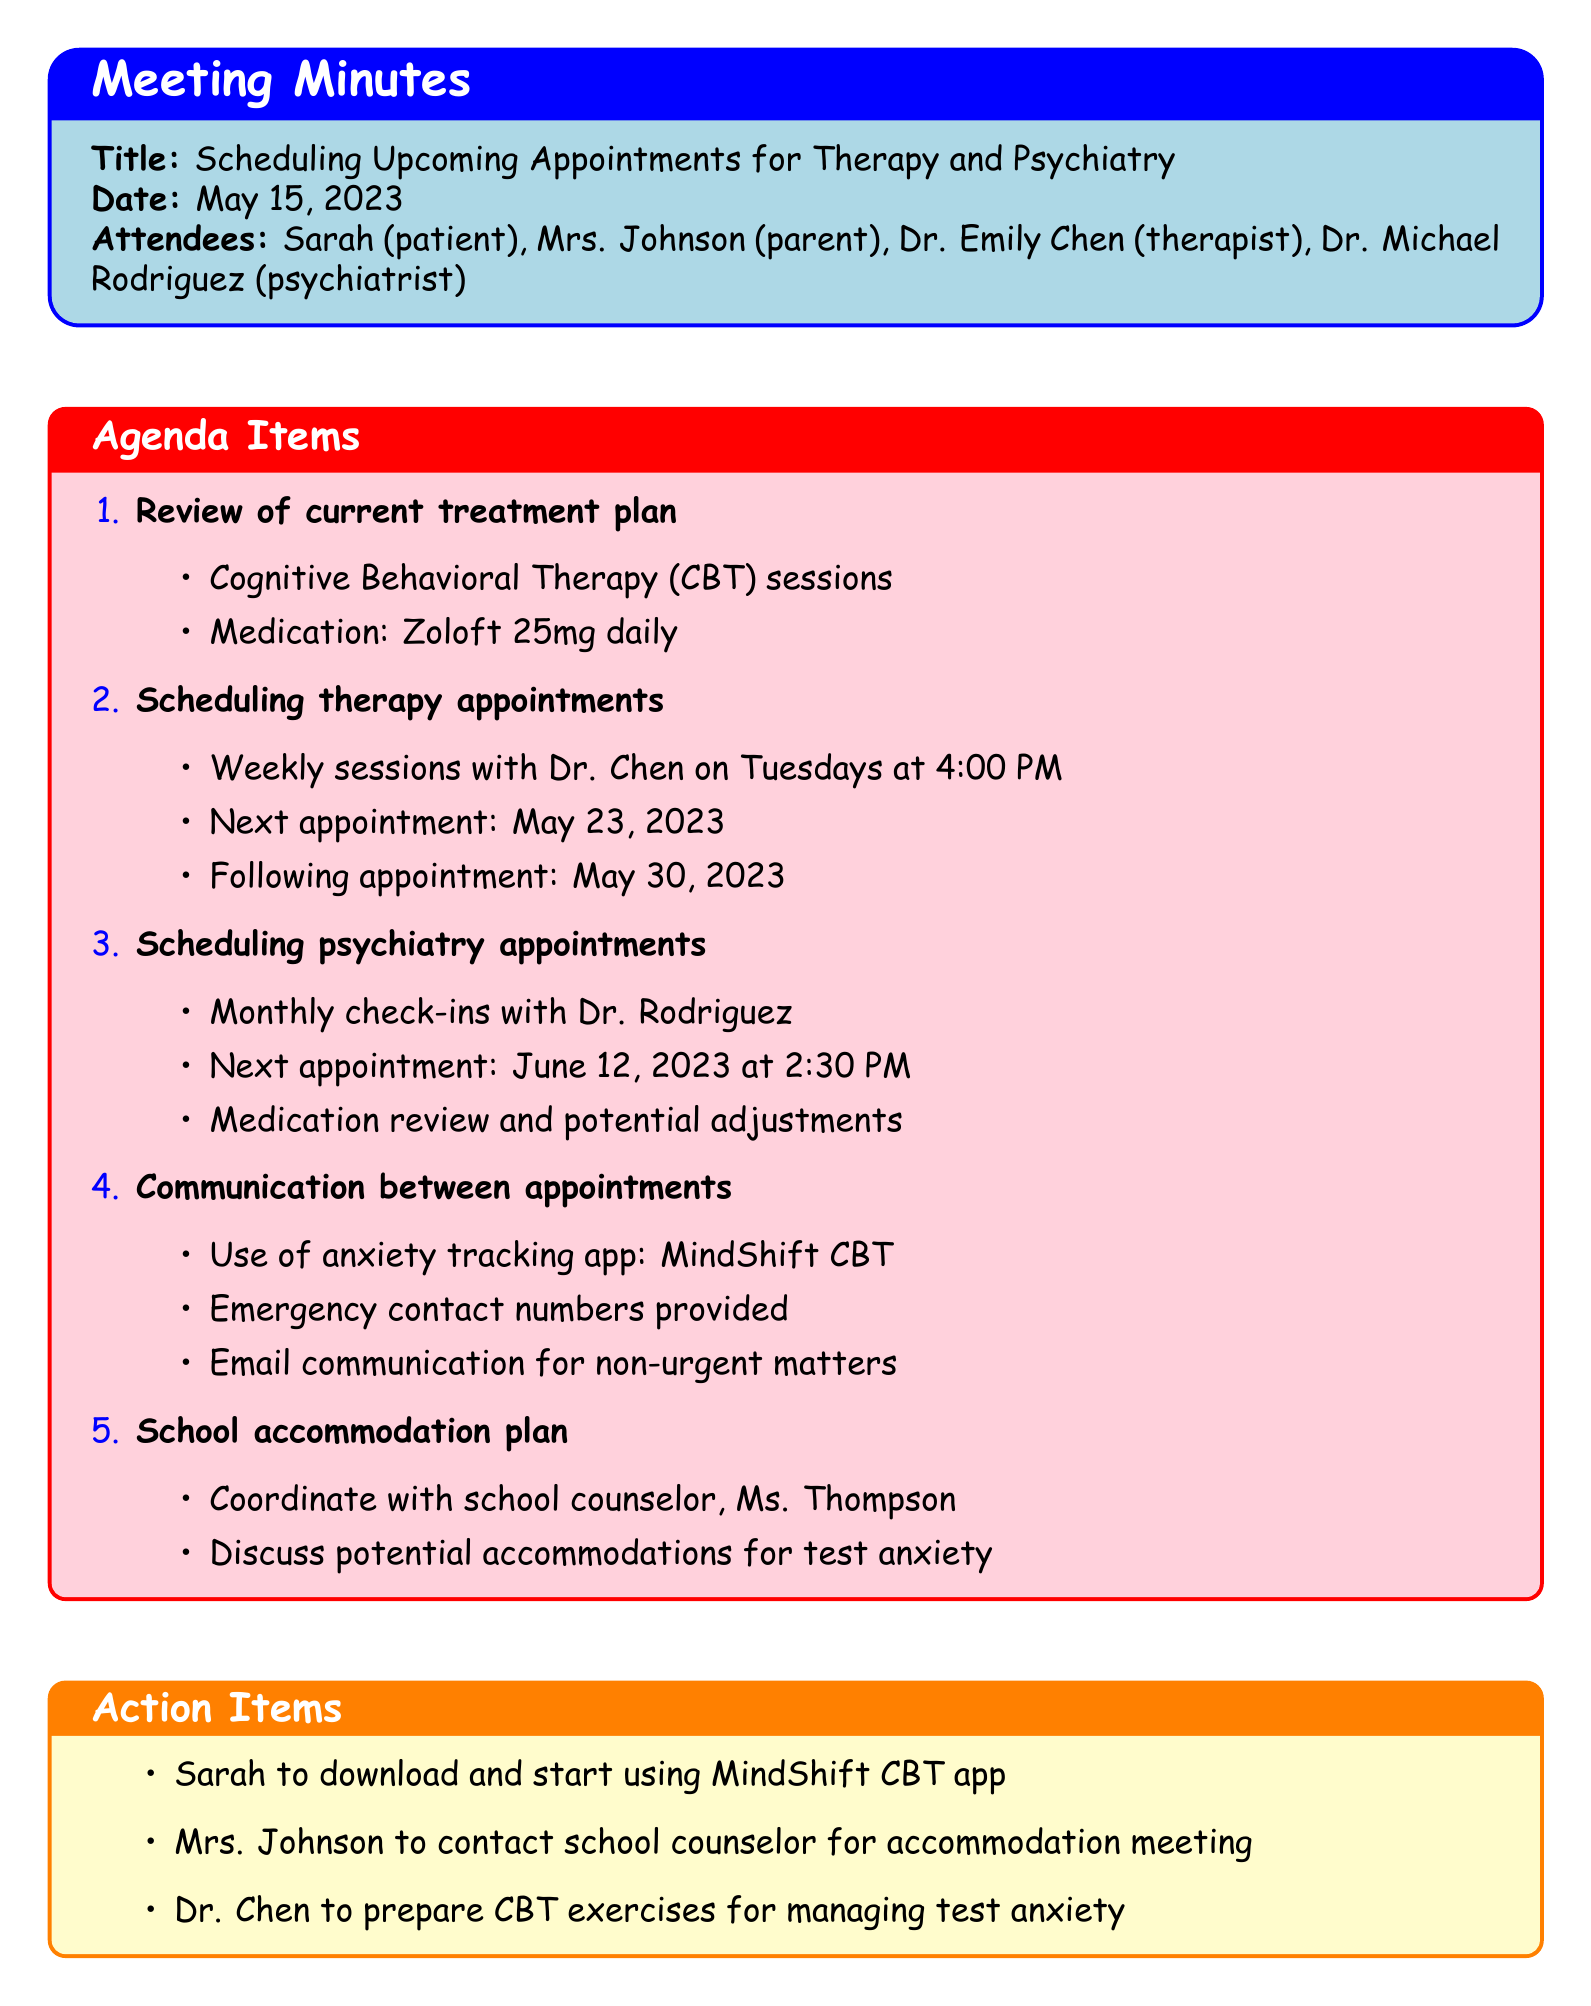What is the meeting title? The meeting title is stated at the beginning of the minutes.
Answer: Scheduling Upcoming Appointments for Therapy and Psychiatry Who is the therapist? The therapist's name is mentioned in the list of attendees.
Answer: Dr. Emily Chen When is the next therapy appointment? The next therapy appointment is specified in the agenda items about scheduling therapy appointments.
Answer: May 23, 2023 What medication is mentioned in the current treatment plan? The medication used in the current treatment plan is listed under the review of the current treatment plan.
Answer: Zoloft 25mg daily How often are psychiatry appointments scheduled? The frequency of psychiatry appointments is detailed in the scheduling section of the minutes.
Answer: Monthly What is the purpose of the MindShift CBT app? The app's purpose is outlined in the communication section of the agenda items.
Answer: Anxiety tracking Who will coordinate with the school counselor? The action item specifies who is responsible for contacting the school counselor.
Answer: Mrs. Johnson What date is the next psychiatry appointment? The next psychiatry appointment is indicated in the scheduling section under psychiatry appointments.
Answer: June 12, 2023 What will Dr. Chen prepare for managing test anxiety? This information is included in the action items listed at the end of the minutes.
Answer: CBT exercises 